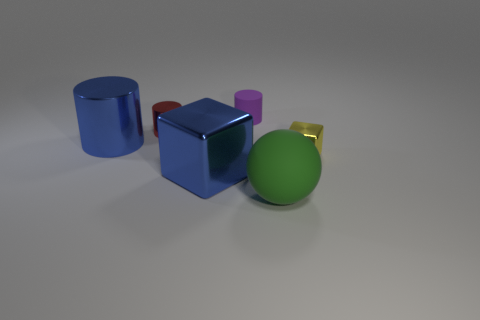Subtract all purple cylinders. How many cylinders are left? 2 Subtract 1 cylinders. How many cylinders are left? 2 Subtract all blocks. How many objects are left? 4 Add 3 spheres. How many objects exist? 9 Add 4 big rubber things. How many big rubber things exist? 5 Subtract 1 purple cylinders. How many objects are left? 5 Subtract all purple things. Subtract all small purple objects. How many objects are left? 4 Add 1 yellow metal objects. How many yellow metal objects are left? 2 